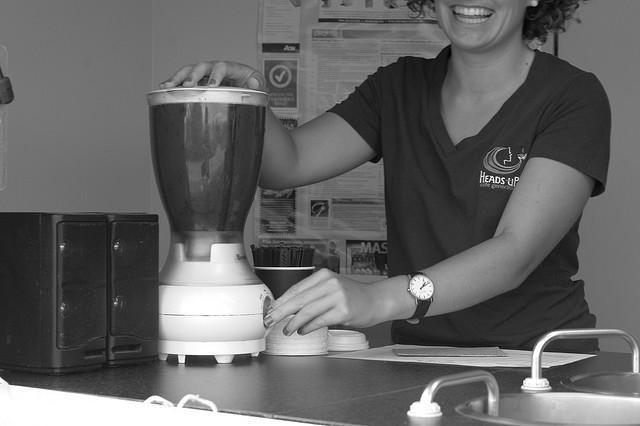How many elephants can you see it's trunk?
Give a very brief answer. 0. 